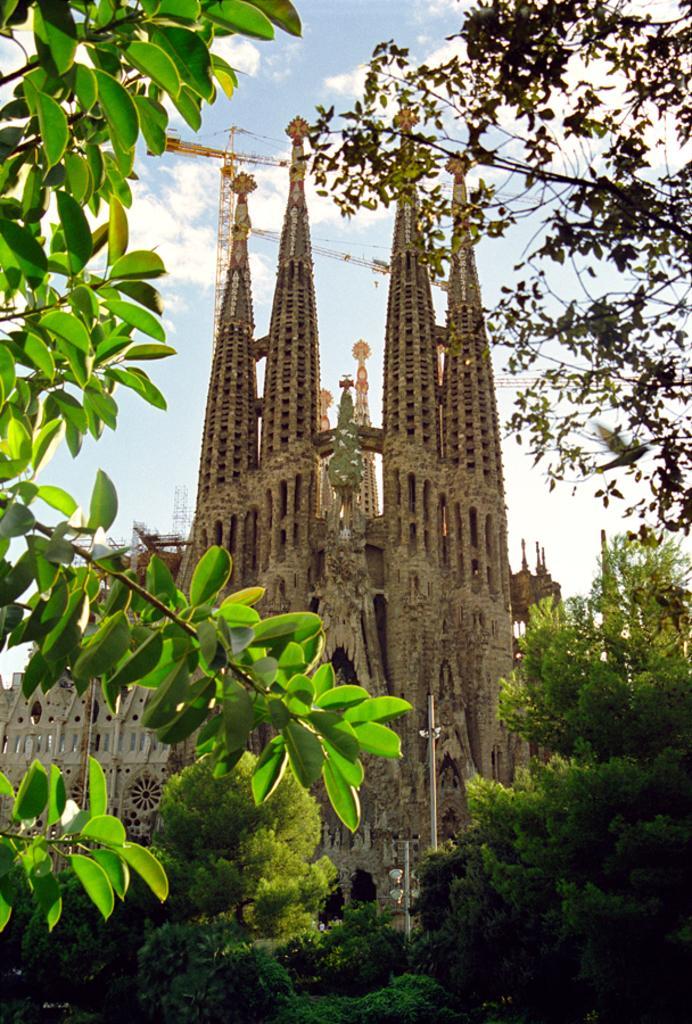How would you summarize this image in a sentence or two? In this image there are leaves on the left corner. There are trees on the right corner and in the foreground. There is a spire, there are poles. And there is sky at the top. 